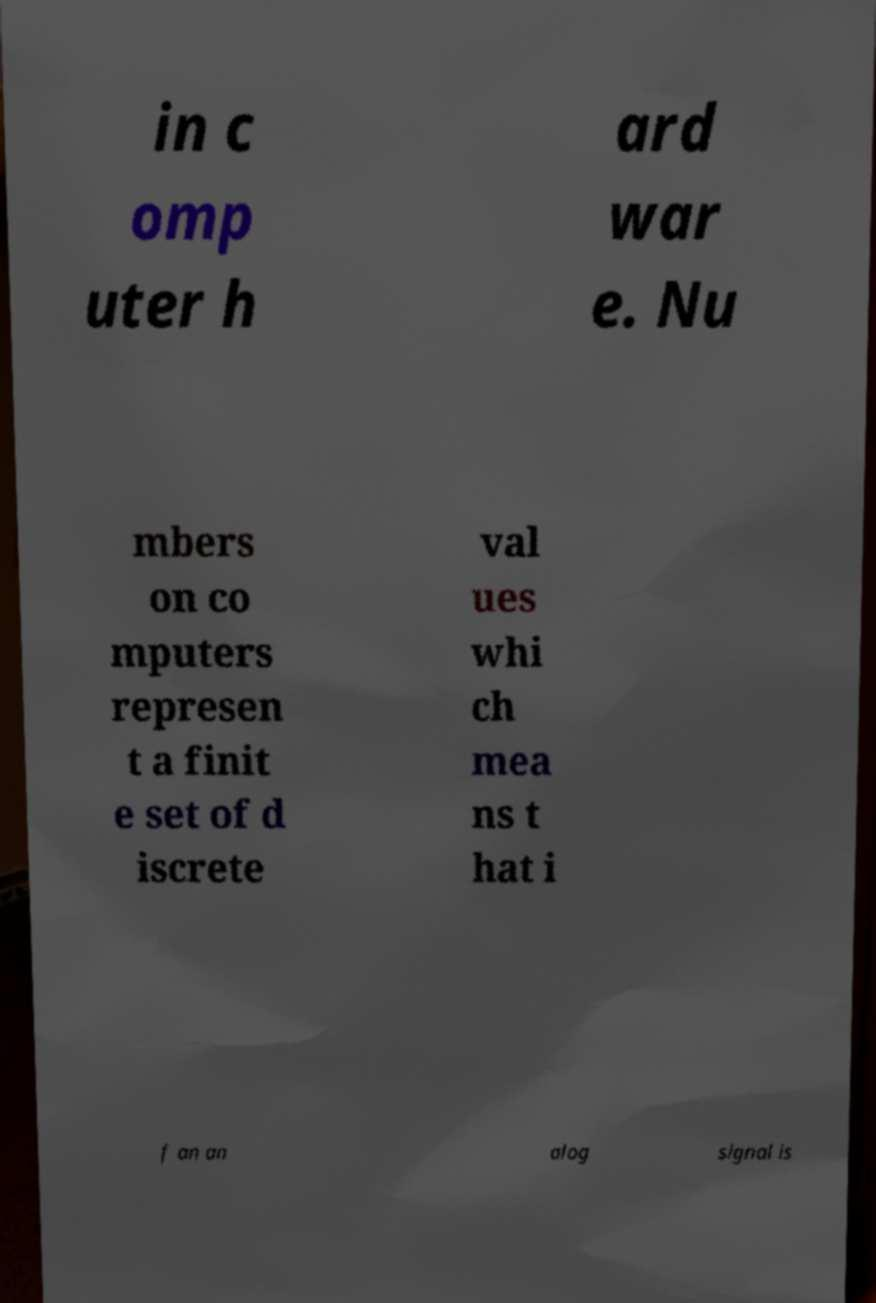Can you accurately transcribe the text from the provided image for me? in c omp uter h ard war e. Nu mbers on co mputers represen t a finit e set of d iscrete val ues whi ch mea ns t hat i f an an alog signal is 